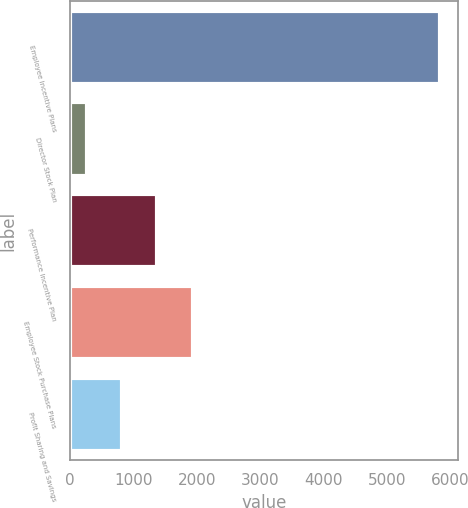<chart> <loc_0><loc_0><loc_500><loc_500><bar_chart><fcel>Employee Incentive Plans<fcel>Director Stock Plan<fcel>Performance Incentive Plan<fcel>Employee Stock Purchase Plans<fcel>Profit Sharing and Savings<nl><fcel>5834<fcel>263<fcel>1377.2<fcel>1934.3<fcel>820.1<nl></chart> 